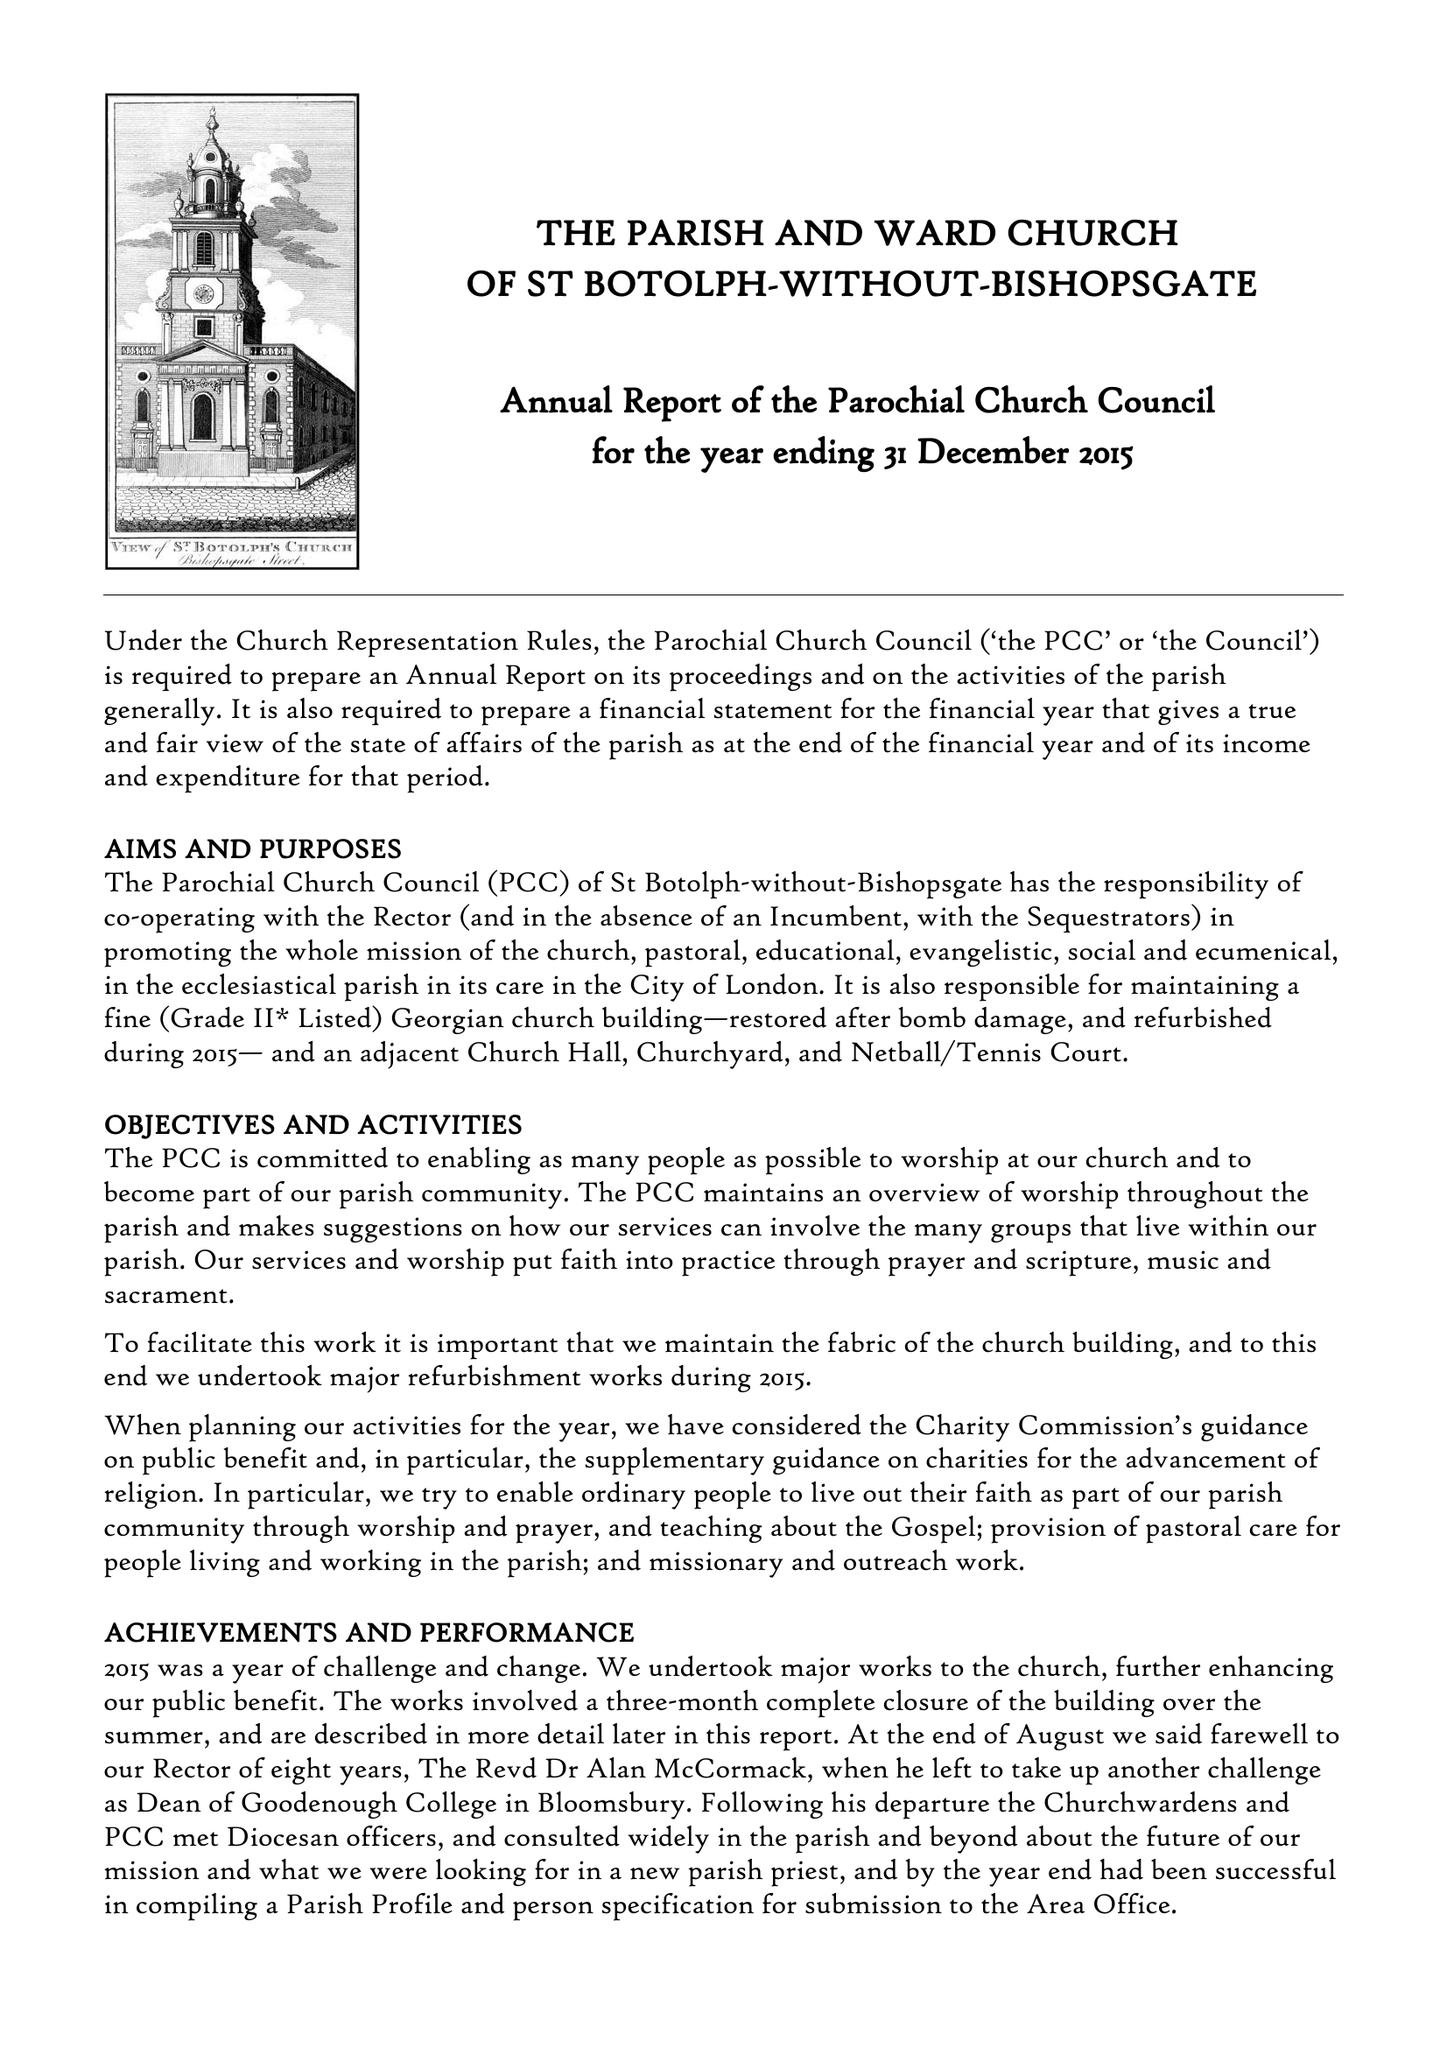What is the value for the address__postcode?
Answer the question using a single word or phrase. EC2M 3TL 